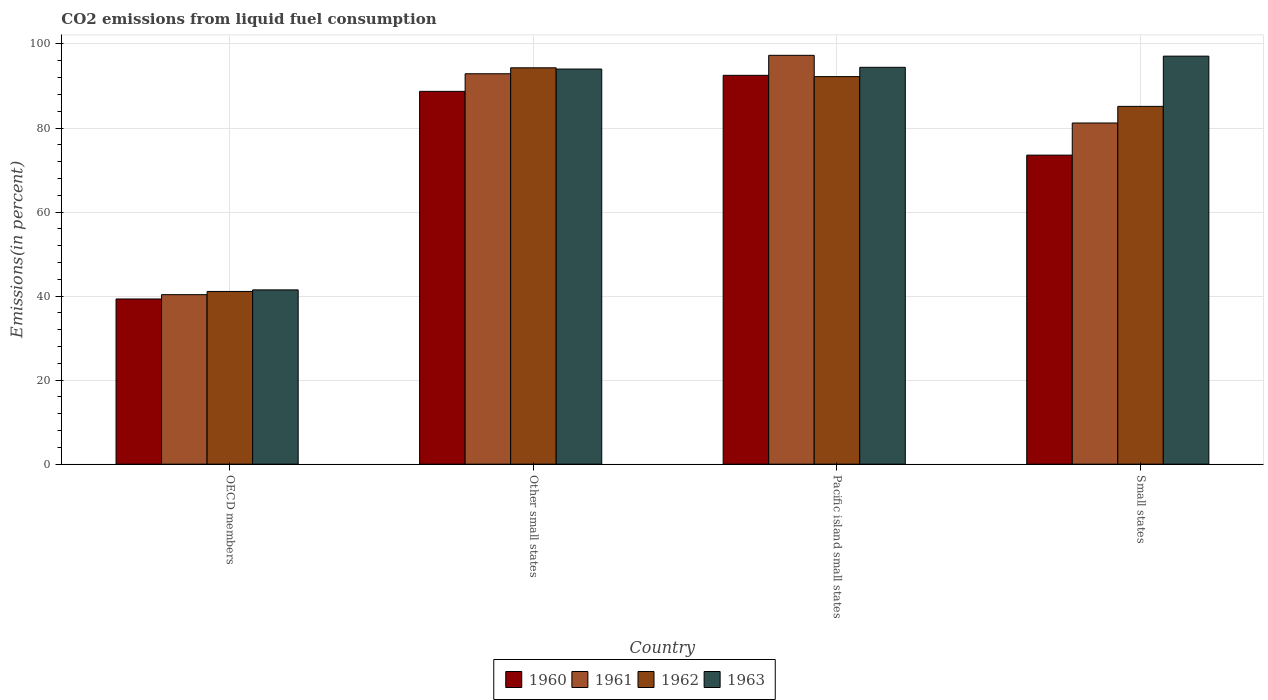Are the number of bars per tick equal to the number of legend labels?
Make the answer very short. Yes. How many bars are there on the 2nd tick from the left?
Ensure brevity in your answer.  4. How many bars are there on the 3rd tick from the right?
Offer a very short reply. 4. What is the label of the 1st group of bars from the left?
Offer a terse response. OECD members. In how many cases, is the number of bars for a given country not equal to the number of legend labels?
Make the answer very short. 0. What is the total CO2 emitted in 1962 in Pacific island small states?
Your answer should be compact. 92.23. Across all countries, what is the maximum total CO2 emitted in 1961?
Provide a succinct answer. 97.3. Across all countries, what is the minimum total CO2 emitted in 1961?
Make the answer very short. 40.34. In which country was the total CO2 emitted in 1963 maximum?
Your answer should be compact. Small states. What is the total total CO2 emitted in 1961 in the graph?
Offer a terse response. 311.74. What is the difference between the total CO2 emitted in 1962 in Other small states and that in Small states?
Give a very brief answer. 9.18. What is the difference between the total CO2 emitted in 1963 in Pacific island small states and the total CO2 emitted in 1962 in Other small states?
Your answer should be very brief. 0.12. What is the average total CO2 emitted in 1963 per country?
Make the answer very short. 81.76. What is the difference between the total CO2 emitted of/in 1963 and total CO2 emitted of/in 1961 in Small states?
Provide a succinct answer. 15.91. What is the ratio of the total CO2 emitted in 1963 in Pacific island small states to that in Small states?
Your answer should be very brief. 0.97. Is the difference between the total CO2 emitted in 1963 in Other small states and Small states greater than the difference between the total CO2 emitted in 1961 in Other small states and Small states?
Keep it short and to the point. No. What is the difference between the highest and the second highest total CO2 emitted in 1961?
Your response must be concise. -16.1. What is the difference between the highest and the lowest total CO2 emitted in 1963?
Make the answer very short. 55.62. Is the sum of the total CO2 emitted in 1963 in Other small states and Pacific island small states greater than the maximum total CO2 emitted in 1961 across all countries?
Give a very brief answer. Yes. What does the 1st bar from the right in Other small states represents?
Provide a succinct answer. 1963. Is it the case that in every country, the sum of the total CO2 emitted in 1962 and total CO2 emitted in 1961 is greater than the total CO2 emitted in 1963?
Your answer should be compact. Yes. How many bars are there?
Offer a very short reply. 16. Does the graph contain any zero values?
Give a very brief answer. No. Does the graph contain grids?
Offer a very short reply. Yes. Where does the legend appear in the graph?
Offer a very short reply. Bottom center. What is the title of the graph?
Offer a very short reply. CO2 emissions from liquid fuel consumption. Does "2009" appear as one of the legend labels in the graph?
Ensure brevity in your answer.  No. What is the label or title of the X-axis?
Keep it short and to the point. Country. What is the label or title of the Y-axis?
Provide a short and direct response. Emissions(in percent). What is the Emissions(in percent) of 1960 in OECD members?
Provide a succinct answer. 39.31. What is the Emissions(in percent) of 1961 in OECD members?
Provide a succinct answer. 40.34. What is the Emissions(in percent) in 1962 in OECD members?
Ensure brevity in your answer.  41.1. What is the Emissions(in percent) of 1963 in OECD members?
Offer a very short reply. 41.48. What is the Emissions(in percent) in 1960 in Other small states?
Provide a succinct answer. 88.72. What is the Emissions(in percent) in 1961 in Other small states?
Offer a terse response. 92.91. What is the Emissions(in percent) of 1962 in Other small states?
Your response must be concise. 94.33. What is the Emissions(in percent) in 1963 in Other small states?
Offer a very short reply. 94.03. What is the Emissions(in percent) of 1960 in Pacific island small states?
Ensure brevity in your answer.  92.54. What is the Emissions(in percent) in 1961 in Pacific island small states?
Offer a terse response. 97.3. What is the Emissions(in percent) in 1962 in Pacific island small states?
Keep it short and to the point. 92.23. What is the Emissions(in percent) in 1963 in Pacific island small states?
Keep it short and to the point. 94.44. What is the Emissions(in percent) of 1960 in Small states?
Keep it short and to the point. 73.54. What is the Emissions(in percent) in 1961 in Small states?
Offer a very short reply. 81.19. What is the Emissions(in percent) of 1962 in Small states?
Give a very brief answer. 85.15. What is the Emissions(in percent) of 1963 in Small states?
Make the answer very short. 97.1. Across all countries, what is the maximum Emissions(in percent) of 1960?
Make the answer very short. 92.54. Across all countries, what is the maximum Emissions(in percent) in 1961?
Your answer should be very brief. 97.3. Across all countries, what is the maximum Emissions(in percent) in 1962?
Give a very brief answer. 94.33. Across all countries, what is the maximum Emissions(in percent) of 1963?
Provide a short and direct response. 97.1. Across all countries, what is the minimum Emissions(in percent) in 1960?
Ensure brevity in your answer.  39.31. Across all countries, what is the minimum Emissions(in percent) of 1961?
Ensure brevity in your answer.  40.34. Across all countries, what is the minimum Emissions(in percent) of 1962?
Your answer should be compact. 41.1. Across all countries, what is the minimum Emissions(in percent) in 1963?
Give a very brief answer. 41.48. What is the total Emissions(in percent) of 1960 in the graph?
Your answer should be very brief. 294.12. What is the total Emissions(in percent) in 1961 in the graph?
Keep it short and to the point. 311.74. What is the total Emissions(in percent) of 1962 in the graph?
Your answer should be very brief. 312.81. What is the total Emissions(in percent) in 1963 in the graph?
Your answer should be compact. 327.05. What is the difference between the Emissions(in percent) in 1960 in OECD members and that in Other small states?
Provide a short and direct response. -49.41. What is the difference between the Emissions(in percent) in 1961 in OECD members and that in Other small states?
Make the answer very short. -52.57. What is the difference between the Emissions(in percent) in 1962 in OECD members and that in Other small states?
Provide a short and direct response. -53.22. What is the difference between the Emissions(in percent) of 1963 in OECD members and that in Other small states?
Provide a succinct answer. -52.55. What is the difference between the Emissions(in percent) in 1960 in OECD members and that in Pacific island small states?
Offer a terse response. -53.23. What is the difference between the Emissions(in percent) of 1961 in OECD members and that in Pacific island small states?
Provide a succinct answer. -56.96. What is the difference between the Emissions(in percent) of 1962 in OECD members and that in Pacific island small states?
Make the answer very short. -51.13. What is the difference between the Emissions(in percent) in 1963 in OECD members and that in Pacific island small states?
Ensure brevity in your answer.  -52.97. What is the difference between the Emissions(in percent) in 1960 in OECD members and that in Small states?
Ensure brevity in your answer.  -34.23. What is the difference between the Emissions(in percent) of 1961 in OECD members and that in Small states?
Your answer should be very brief. -40.85. What is the difference between the Emissions(in percent) of 1962 in OECD members and that in Small states?
Your answer should be very brief. -44.04. What is the difference between the Emissions(in percent) of 1963 in OECD members and that in Small states?
Offer a terse response. -55.62. What is the difference between the Emissions(in percent) in 1960 in Other small states and that in Pacific island small states?
Offer a very short reply. -3.82. What is the difference between the Emissions(in percent) of 1961 in Other small states and that in Pacific island small states?
Provide a succinct answer. -4.39. What is the difference between the Emissions(in percent) of 1962 in Other small states and that in Pacific island small states?
Provide a short and direct response. 2.09. What is the difference between the Emissions(in percent) of 1963 in Other small states and that in Pacific island small states?
Make the answer very short. -0.41. What is the difference between the Emissions(in percent) in 1960 in Other small states and that in Small states?
Give a very brief answer. 15.18. What is the difference between the Emissions(in percent) in 1961 in Other small states and that in Small states?
Your response must be concise. 11.72. What is the difference between the Emissions(in percent) of 1962 in Other small states and that in Small states?
Provide a short and direct response. 9.18. What is the difference between the Emissions(in percent) in 1963 in Other small states and that in Small states?
Offer a very short reply. -3.07. What is the difference between the Emissions(in percent) of 1960 in Pacific island small states and that in Small states?
Offer a very short reply. 18.99. What is the difference between the Emissions(in percent) of 1961 in Pacific island small states and that in Small states?
Ensure brevity in your answer.  16.1. What is the difference between the Emissions(in percent) in 1962 in Pacific island small states and that in Small states?
Your answer should be compact. 7.09. What is the difference between the Emissions(in percent) in 1963 in Pacific island small states and that in Small states?
Give a very brief answer. -2.66. What is the difference between the Emissions(in percent) of 1960 in OECD members and the Emissions(in percent) of 1961 in Other small states?
Provide a short and direct response. -53.6. What is the difference between the Emissions(in percent) of 1960 in OECD members and the Emissions(in percent) of 1962 in Other small states?
Give a very brief answer. -55.01. What is the difference between the Emissions(in percent) in 1960 in OECD members and the Emissions(in percent) in 1963 in Other small states?
Give a very brief answer. -54.72. What is the difference between the Emissions(in percent) of 1961 in OECD members and the Emissions(in percent) of 1962 in Other small states?
Your response must be concise. -53.99. What is the difference between the Emissions(in percent) in 1961 in OECD members and the Emissions(in percent) in 1963 in Other small states?
Your response must be concise. -53.69. What is the difference between the Emissions(in percent) in 1962 in OECD members and the Emissions(in percent) in 1963 in Other small states?
Offer a terse response. -52.93. What is the difference between the Emissions(in percent) in 1960 in OECD members and the Emissions(in percent) in 1961 in Pacific island small states?
Ensure brevity in your answer.  -57.99. What is the difference between the Emissions(in percent) in 1960 in OECD members and the Emissions(in percent) in 1962 in Pacific island small states?
Your answer should be very brief. -52.92. What is the difference between the Emissions(in percent) in 1960 in OECD members and the Emissions(in percent) in 1963 in Pacific island small states?
Keep it short and to the point. -55.13. What is the difference between the Emissions(in percent) of 1961 in OECD members and the Emissions(in percent) of 1962 in Pacific island small states?
Your response must be concise. -51.89. What is the difference between the Emissions(in percent) in 1961 in OECD members and the Emissions(in percent) in 1963 in Pacific island small states?
Offer a very short reply. -54.1. What is the difference between the Emissions(in percent) in 1962 in OECD members and the Emissions(in percent) in 1963 in Pacific island small states?
Provide a short and direct response. -53.34. What is the difference between the Emissions(in percent) of 1960 in OECD members and the Emissions(in percent) of 1961 in Small states?
Your response must be concise. -41.88. What is the difference between the Emissions(in percent) in 1960 in OECD members and the Emissions(in percent) in 1962 in Small states?
Offer a very short reply. -45.84. What is the difference between the Emissions(in percent) of 1960 in OECD members and the Emissions(in percent) of 1963 in Small states?
Keep it short and to the point. -57.79. What is the difference between the Emissions(in percent) of 1961 in OECD members and the Emissions(in percent) of 1962 in Small states?
Offer a terse response. -44.81. What is the difference between the Emissions(in percent) in 1961 in OECD members and the Emissions(in percent) in 1963 in Small states?
Offer a very short reply. -56.76. What is the difference between the Emissions(in percent) of 1962 in OECD members and the Emissions(in percent) of 1963 in Small states?
Give a very brief answer. -55.99. What is the difference between the Emissions(in percent) in 1960 in Other small states and the Emissions(in percent) in 1961 in Pacific island small states?
Make the answer very short. -8.58. What is the difference between the Emissions(in percent) in 1960 in Other small states and the Emissions(in percent) in 1962 in Pacific island small states?
Offer a very short reply. -3.51. What is the difference between the Emissions(in percent) of 1960 in Other small states and the Emissions(in percent) of 1963 in Pacific island small states?
Your answer should be compact. -5.72. What is the difference between the Emissions(in percent) in 1961 in Other small states and the Emissions(in percent) in 1962 in Pacific island small states?
Keep it short and to the point. 0.67. What is the difference between the Emissions(in percent) in 1961 in Other small states and the Emissions(in percent) in 1963 in Pacific island small states?
Keep it short and to the point. -1.54. What is the difference between the Emissions(in percent) in 1962 in Other small states and the Emissions(in percent) in 1963 in Pacific island small states?
Give a very brief answer. -0.12. What is the difference between the Emissions(in percent) of 1960 in Other small states and the Emissions(in percent) of 1961 in Small states?
Ensure brevity in your answer.  7.53. What is the difference between the Emissions(in percent) in 1960 in Other small states and the Emissions(in percent) in 1962 in Small states?
Give a very brief answer. 3.57. What is the difference between the Emissions(in percent) in 1960 in Other small states and the Emissions(in percent) in 1963 in Small states?
Offer a terse response. -8.38. What is the difference between the Emissions(in percent) of 1961 in Other small states and the Emissions(in percent) of 1962 in Small states?
Your response must be concise. 7.76. What is the difference between the Emissions(in percent) of 1961 in Other small states and the Emissions(in percent) of 1963 in Small states?
Make the answer very short. -4.19. What is the difference between the Emissions(in percent) in 1962 in Other small states and the Emissions(in percent) in 1963 in Small states?
Your response must be concise. -2.77. What is the difference between the Emissions(in percent) in 1960 in Pacific island small states and the Emissions(in percent) in 1961 in Small states?
Provide a succinct answer. 11.34. What is the difference between the Emissions(in percent) in 1960 in Pacific island small states and the Emissions(in percent) in 1962 in Small states?
Make the answer very short. 7.39. What is the difference between the Emissions(in percent) in 1960 in Pacific island small states and the Emissions(in percent) in 1963 in Small states?
Ensure brevity in your answer.  -4.56. What is the difference between the Emissions(in percent) of 1961 in Pacific island small states and the Emissions(in percent) of 1962 in Small states?
Give a very brief answer. 12.15. What is the difference between the Emissions(in percent) of 1961 in Pacific island small states and the Emissions(in percent) of 1963 in Small states?
Offer a very short reply. 0.2. What is the difference between the Emissions(in percent) of 1962 in Pacific island small states and the Emissions(in percent) of 1963 in Small states?
Your response must be concise. -4.87. What is the average Emissions(in percent) of 1960 per country?
Ensure brevity in your answer.  73.53. What is the average Emissions(in percent) of 1961 per country?
Offer a very short reply. 77.93. What is the average Emissions(in percent) in 1962 per country?
Make the answer very short. 78.2. What is the average Emissions(in percent) of 1963 per country?
Offer a terse response. 81.76. What is the difference between the Emissions(in percent) in 1960 and Emissions(in percent) in 1961 in OECD members?
Provide a short and direct response. -1.03. What is the difference between the Emissions(in percent) in 1960 and Emissions(in percent) in 1962 in OECD members?
Ensure brevity in your answer.  -1.79. What is the difference between the Emissions(in percent) in 1960 and Emissions(in percent) in 1963 in OECD members?
Give a very brief answer. -2.16. What is the difference between the Emissions(in percent) of 1961 and Emissions(in percent) of 1962 in OECD members?
Provide a succinct answer. -0.76. What is the difference between the Emissions(in percent) of 1961 and Emissions(in percent) of 1963 in OECD members?
Your answer should be compact. -1.14. What is the difference between the Emissions(in percent) of 1962 and Emissions(in percent) of 1963 in OECD members?
Offer a terse response. -0.37. What is the difference between the Emissions(in percent) of 1960 and Emissions(in percent) of 1961 in Other small states?
Your answer should be very brief. -4.19. What is the difference between the Emissions(in percent) of 1960 and Emissions(in percent) of 1962 in Other small states?
Offer a very short reply. -5.6. What is the difference between the Emissions(in percent) of 1960 and Emissions(in percent) of 1963 in Other small states?
Ensure brevity in your answer.  -5.31. What is the difference between the Emissions(in percent) of 1961 and Emissions(in percent) of 1962 in Other small states?
Your answer should be compact. -1.42. What is the difference between the Emissions(in percent) of 1961 and Emissions(in percent) of 1963 in Other small states?
Make the answer very short. -1.12. What is the difference between the Emissions(in percent) of 1962 and Emissions(in percent) of 1963 in Other small states?
Provide a succinct answer. 0.3. What is the difference between the Emissions(in percent) of 1960 and Emissions(in percent) of 1961 in Pacific island small states?
Provide a succinct answer. -4.76. What is the difference between the Emissions(in percent) of 1960 and Emissions(in percent) of 1962 in Pacific island small states?
Your answer should be very brief. 0.3. What is the difference between the Emissions(in percent) of 1960 and Emissions(in percent) of 1963 in Pacific island small states?
Make the answer very short. -1.91. What is the difference between the Emissions(in percent) of 1961 and Emissions(in percent) of 1962 in Pacific island small states?
Your answer should be very brief. 5.06. What is the difference between the Emissions(in percent) in 1961 and Emissions(in percent) in 1963 in Pacific island small states?
Provide a succinct answer. 2.85. What is the difference between the Emissions(in percent) of 1962 and Emissions(in percent) of 1963 in Pacific island small states?
Offer a very short reply. -2.21. What is the difference between the Emissions(in percent) in 1960 and Emissions(in percent) in 1961 in Small states?
Provide a succinct answer. -7.65. What is the difference between the Emissions(in percent) of 1960 and Emissions(in percent) of 1962 in Small states?
Your answer should be very brief. -11.6. What is the difference between the Emissions(in percent) of 1960 and Emissions(in percent) of 1963 in Small states?
Keep it short and to the point. -23.56. What is the difference between the Emissions(in percent) of 1961 and Emissions(in percent) of 1962 in Small states?
Offer a terse response. -3.96. What is the difference between the Emissions(in percent) in 1961 and Emissions(in percent) in 1963 in Small states?
Ensure brevity in your answer.  -15.91. What is the difference between the Emissions(in percent) of 1962 and Emissions(in percent) of 1963 in Small states?
Keep it short and to the point. -11.95. What is the ratio of the Emissions(in percent) of 1960 in OECD members to that in Other small states?
Make the answer very short. 0.44. What is the ratio of the Emissions(in percent) in 1961 in OECD members to that in Other small states?
Offer a very short reply. 0.43. What is the ratio of the Emissions(in percent) of 1962 in OECD members to that in Other small states?
Give a very brief answer. 0.44. What is the ratio of the Emissions(in percent) in 1963 in OECD members to that in Other small states?
Provide a succinct answer. 0.44. What is the ratio of the Emissions(in percent) in 1960 in OECD members to that in Pacific island small states?
Give a very brief answer. 0.42. What is the ratio of the Emissions(in percent) in 1961 in OECD members to that in Pacific island small states?
Keep it short and to the point. 0.41. What is the ratio of the Emissions(in percent) of 1962 in OECD members to that in Pacific island small states?
Make the answer very short. 0.45. What is the ratio of the Emissions(in percent) in 1963 in OECD members to that in Pacific island small states?
Your answer should be compact. 0.44. What is the ratio of the Emissions(in percent) in 1960 in OECD members to that in Small states?
Provide a short and direct response. 0.53. What is the ratio of the Emissions(in percent) in 1961 in OECD members to that in Small states?
Offer a very short reply. 0.5. What is the ratio of the Emissions(in percent) in 1962 in OECD members to that in Small states?
Make the answer very short. 0.48. What is the ratio of the Emissions(in percent) of 1963 in OECD members to that in Small states?
Provide a succinct answer. 0.43. What is the ratio of the Emissions(in percent) in 1960 in Other small states to that in Pacific island small states?
Offer a very short reply. 0.96. What is the ratio of the Emissions(in percent) of 1961 in Other small states to that in Pacific island small states?
Offer a very short reply. 0.95. What is the ratio of the Emissions(in percent) of 1962 in Other small states to that in Pacific island small states?
Offer a terse response. 1.02. What is the ratio of the Emissions(in percent) of 1963 in Other small states to that in Pacific island small states?
Ensure brevity in your answer.  1. What is the ratio of the Emissions(in percent) of 1960 in Other small states to that in Small states?
Offer a terse response. 1.21. What is the ratio of the Emissions(in percent) of 1961 in Other small states to that in Small states?
Your answer should be very brief. 1.14. What is the ratio of the Emissions(in percent) in 1962 in Other small states to that in Small states?
Offer a very short reply. 1.11. What is the ratio of the Emissions(in percent) in 1963 in Other small states to that in Small states?
Make the answer very short. 0.97. What is the ratio of the Emissions(in percent) in 1960 in Pacific island small states to that in Small states?
Offer a terse response. 1.26. What is the ratio of the Emissions(in percent) of 1961 in Pacific island small states to that in Small states?
Provide a succinct answer. 1.2. What is the ratio of the Emissions(in percent) in 1962 in Pacific island small states to that in Small states?
Your answer should be very brief. 1.08. What is the ratio of the Emissions(in percent) in 1963 in Pacific island small states to that in Small states?
Your answer should be compact. 0.97. What is the difference between the highest and the second highest Emissions(in percent) in 1960?
Offer a terse response. 3.82. What is the difference between the highest and the second highest Emissions(in percent) in 1961?
Give a very brief answer. 4.39. What is the difference between the highest and the second highest Emissions(in percent) in 1962?
Your answer should be very brief. 2.09. What is the difference between the highest and the second highest Emissions(in percent) in 1963?
Offer a very short reply. 2.66. What is the difference between the highest and the lowest Emissions(in percent) of 1960?
Ensure brevity in your answer.  53.23. What is the difference between the highest and the lowest Emissions(in percent) of 1961?
Give a very brief answer. 56.96. What is the difference between the highest and the lowest Emissions(in percent) in 1962?
Your answer should be compact. 53.22. What is the difference between the highest and the lowest Emissions(in percent) of 1963?
Offer a very short reply. 55.62. 